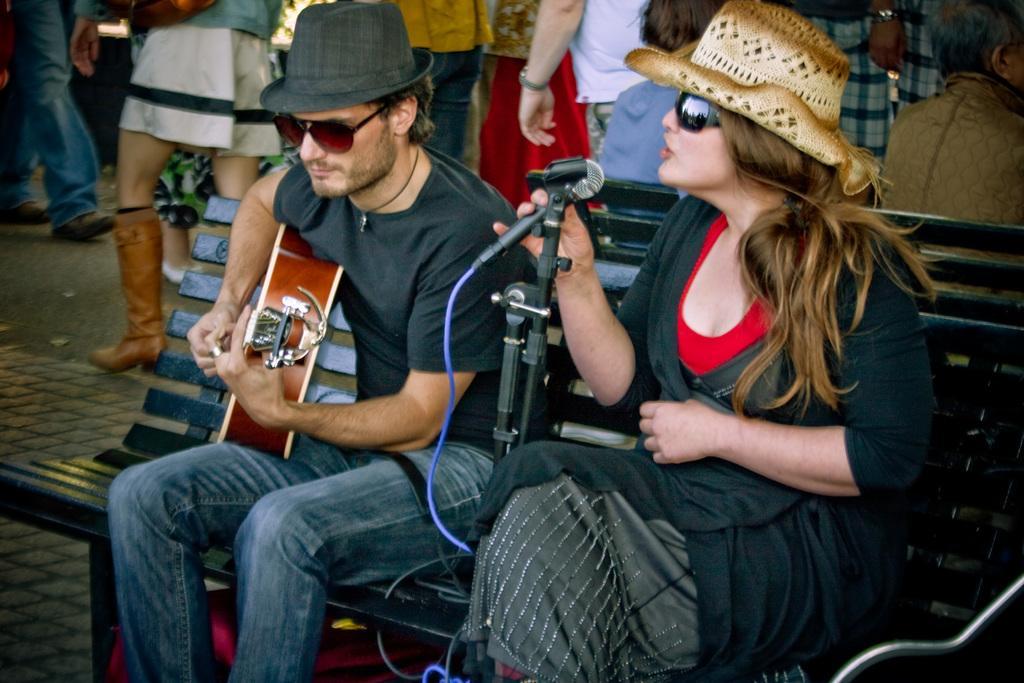In one or two sentences, can you explain what this image depicts? A woman is sitting on a bench and singing with a mic in her hand. There is man beside her playing guitar. He wears hat and goggles. There are some people behind them. 